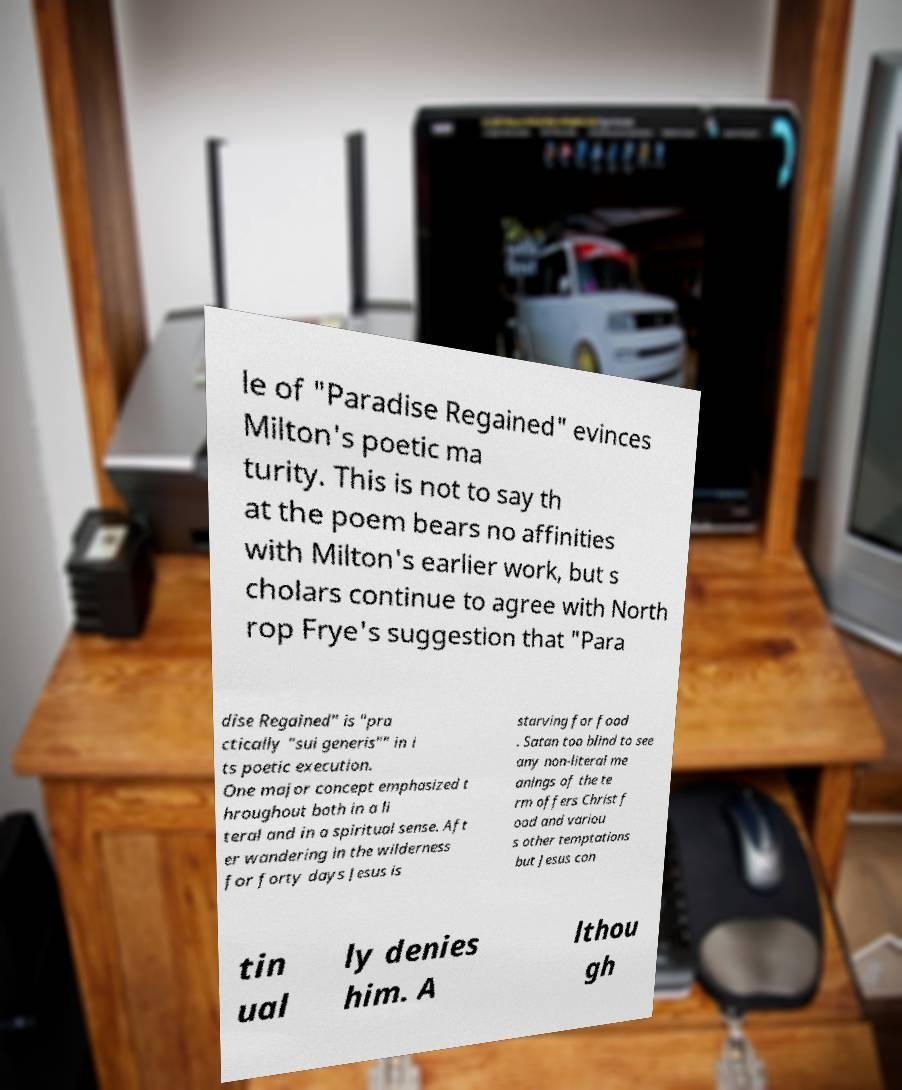Could you extract and type out the text from this image? le of "Paradise Regained" evinces Milton's poetic ma turity. This is not to say th at the poem bears no affinities with Milton's earlier work, but s cholars continue to agree with North rop Frye's suggestion that "Para dise Regained" is "pra ctically "sui generis"" in i ts poetic execution. One major concept emphasized t hroughout both in a li teral and in a spiritual sense. Aft er wandering in the wilderness for forty days Jesus is starving for food . Satan too blind to see any non-literal me anings of the te rm offers Christ f ood and variou s other temptations but Jesus con tin ual ly denies him. A lthou gh 